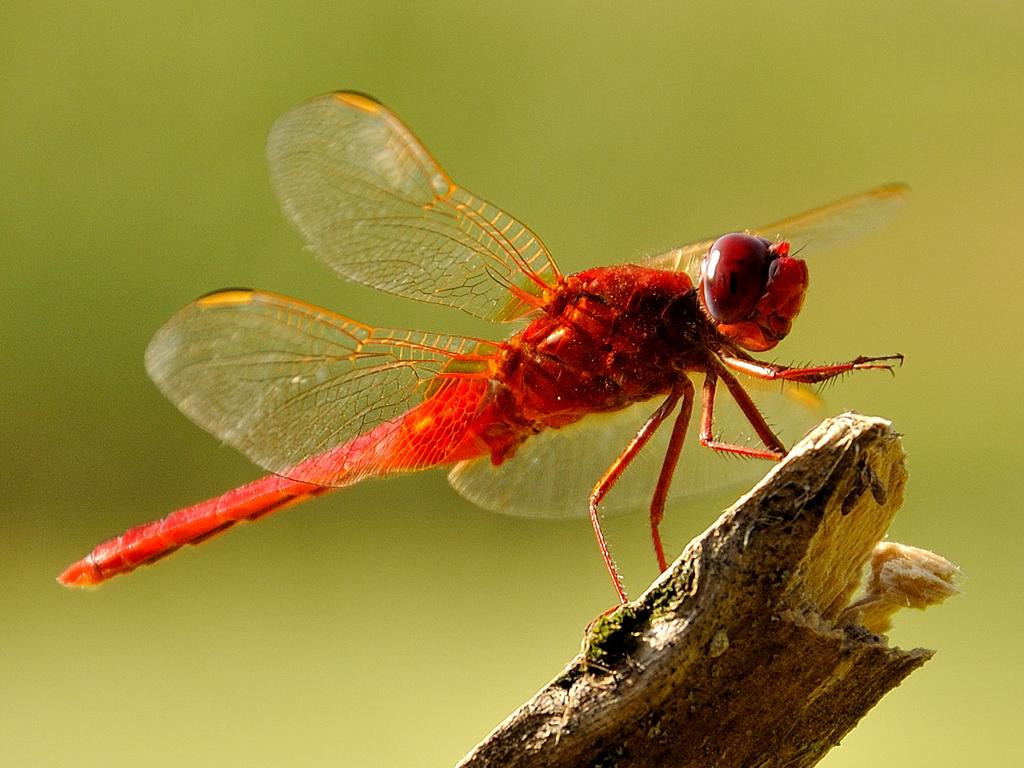What is the main subject of the image? There is a dragonfly in the image. What is the dragonfly resting on? The dragonfly is on a wooden stick. How would you describe the background of the image? The background of the image is blurry. What type of skirt is hanging on the shelf in the image? There is no shelf or skirt present in the image; it features a dragonfly on a wooden stick with a blurry background. 